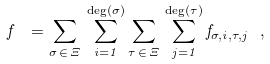Convert formula to latex. <formula><loc_0><loc_0><loc_500><loc_500>f \ = { \underset { \sigma \, \in \, \Xi } \sum } \, \sum ^ { \deg ( \sigma ) } _ { i = 1 } { \underset { \tau \, \in \, \Xi } \sum } \, \sum ^ { \deg ( \tau ) } _ { j = 1 } f _ { \sigma , i , \tau , j } \ ,</formula> 